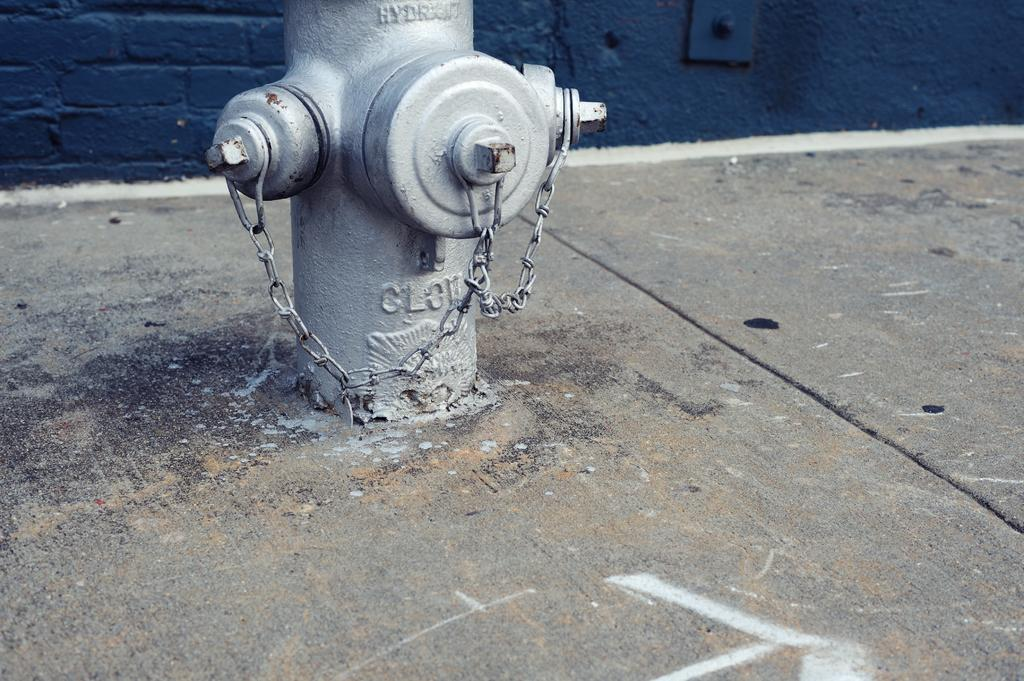What is on the left side of the image? There is a gray color pole on the left side of the image. What features does the pole have? The pole has two chains and three valves. Where is the pole located? The pole is located on a footpath. What can be seen in the background of the image? There is a violet color wall in the background of the image. How many oranges are hanging from the pole in the image? There are no oranges present in the image; the pole has chains and valves. Is there any poison visible in the image? There is no poison present in the image. 